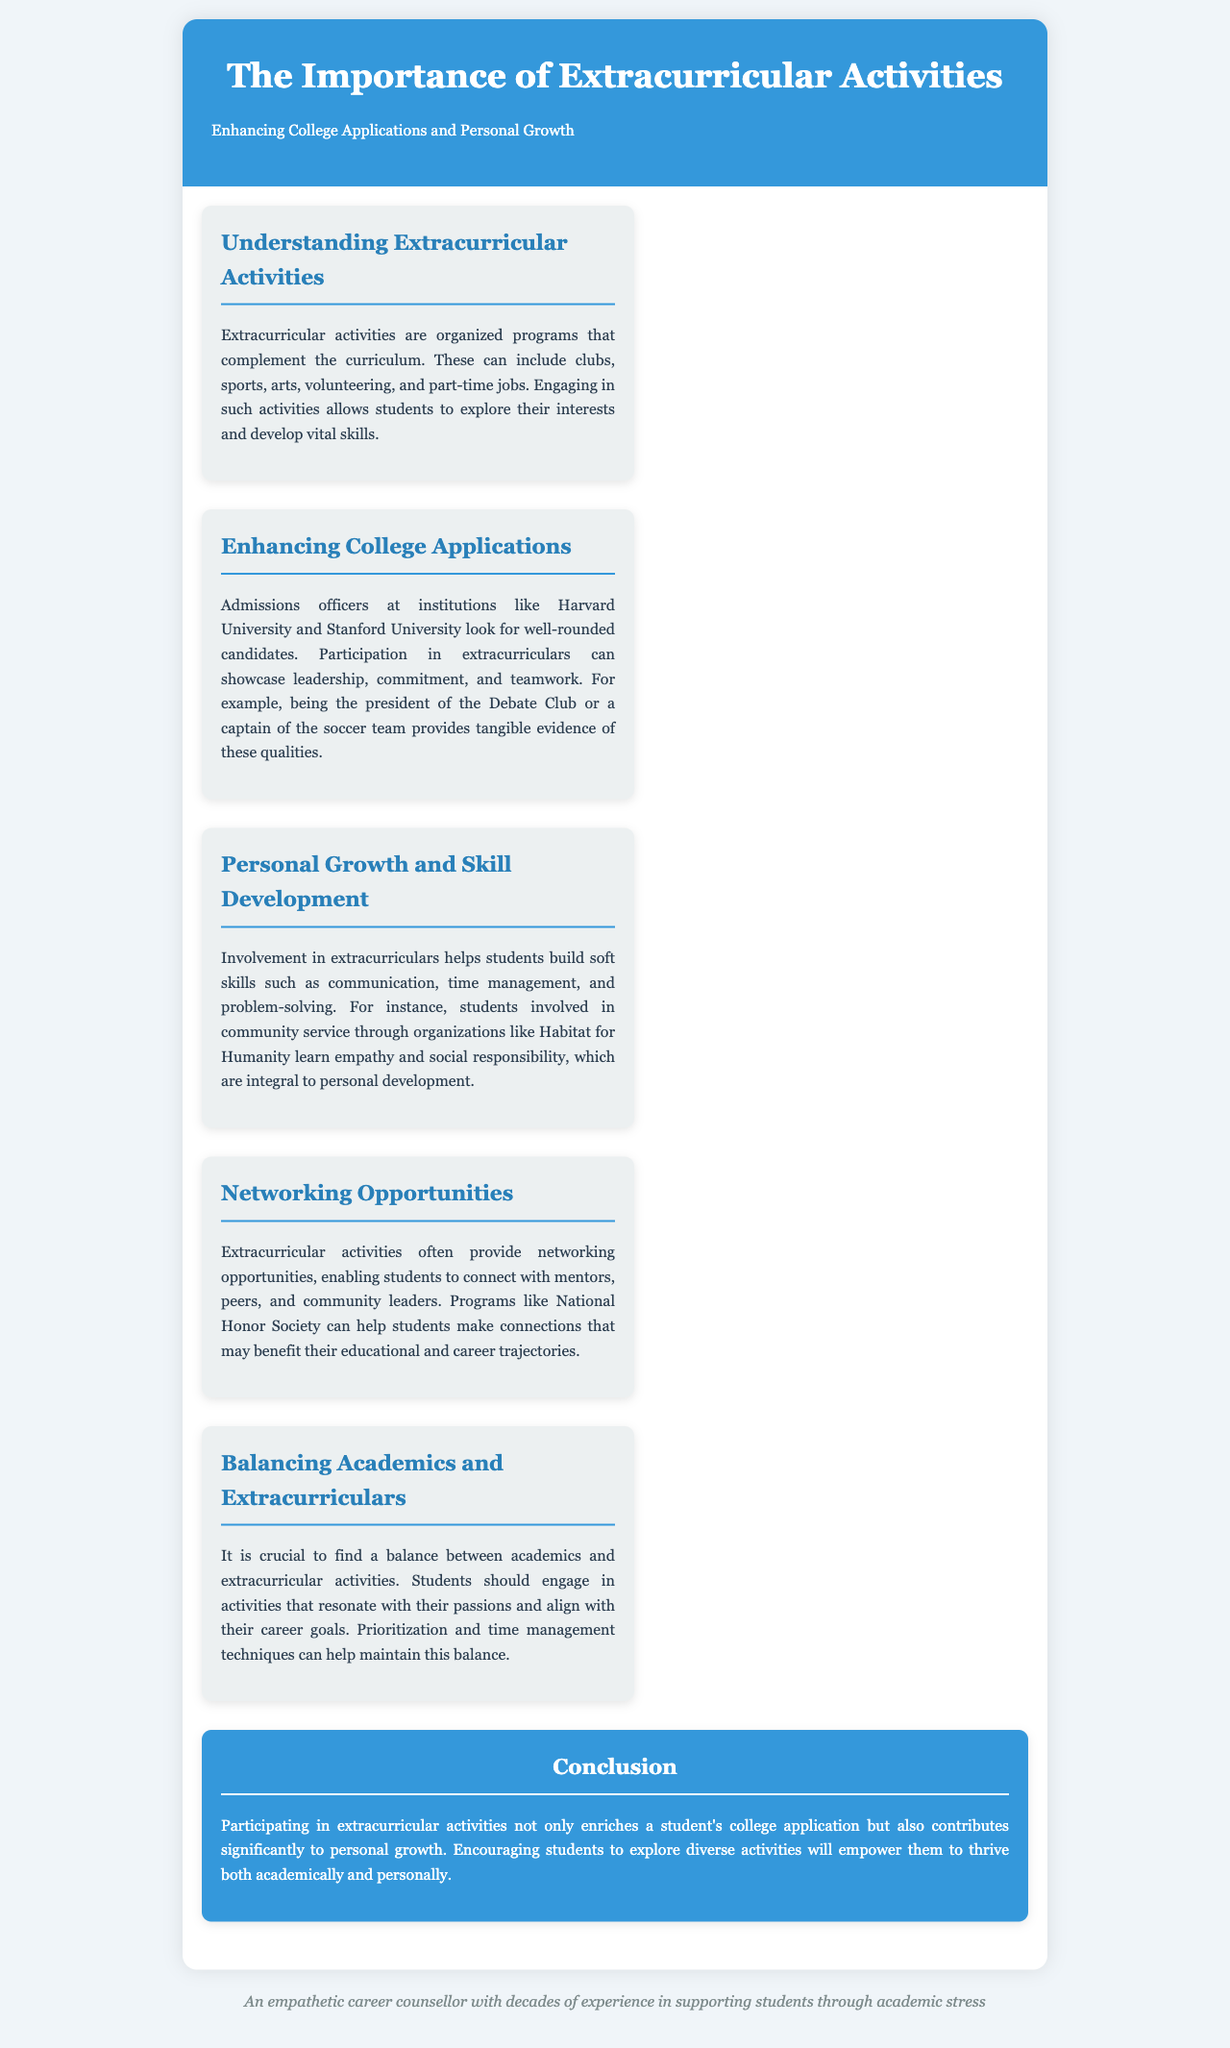What are extracurricular activities? Extracurricular activities are defined as organized programs that complement the curriculum, including clubs, sports, arts, volunteering, and part-time jobs.
Answer: Organized programs Who looks for well-rounded candidates in college applications? Admissions officers at institutions like Harvard University and Stanford University look for well-rounded candidates.
Answer: Admissions officers What skills can be developed through extracurricular activities? Involvement in extracurriculars helps students build soft skills such as communication, time management, and problem-solving.
Answer: Soft skills What organization can help students make connections? Programs like National Honor Society can help students make connections that may benefit their educational and career trajectories.
Answer: National Honor Society What is essential for balancing academics and extracurricular activities? Prioritization and time management techniques are essential to maintain a balance between academics and extracurricular activities.
Answer: Time management techniques What is the conclusion about extracurricular activities? The conclusion emphasizes that participating in extracurricular activities enriches a student's college application and contributes significantly to personal growth.
Answer: Enriches college application What type of growth is discussed in the brochure? Personal growth is discussed in the context of skills and experiences gained through extracurricular involvement.
Answer: Personal growth 